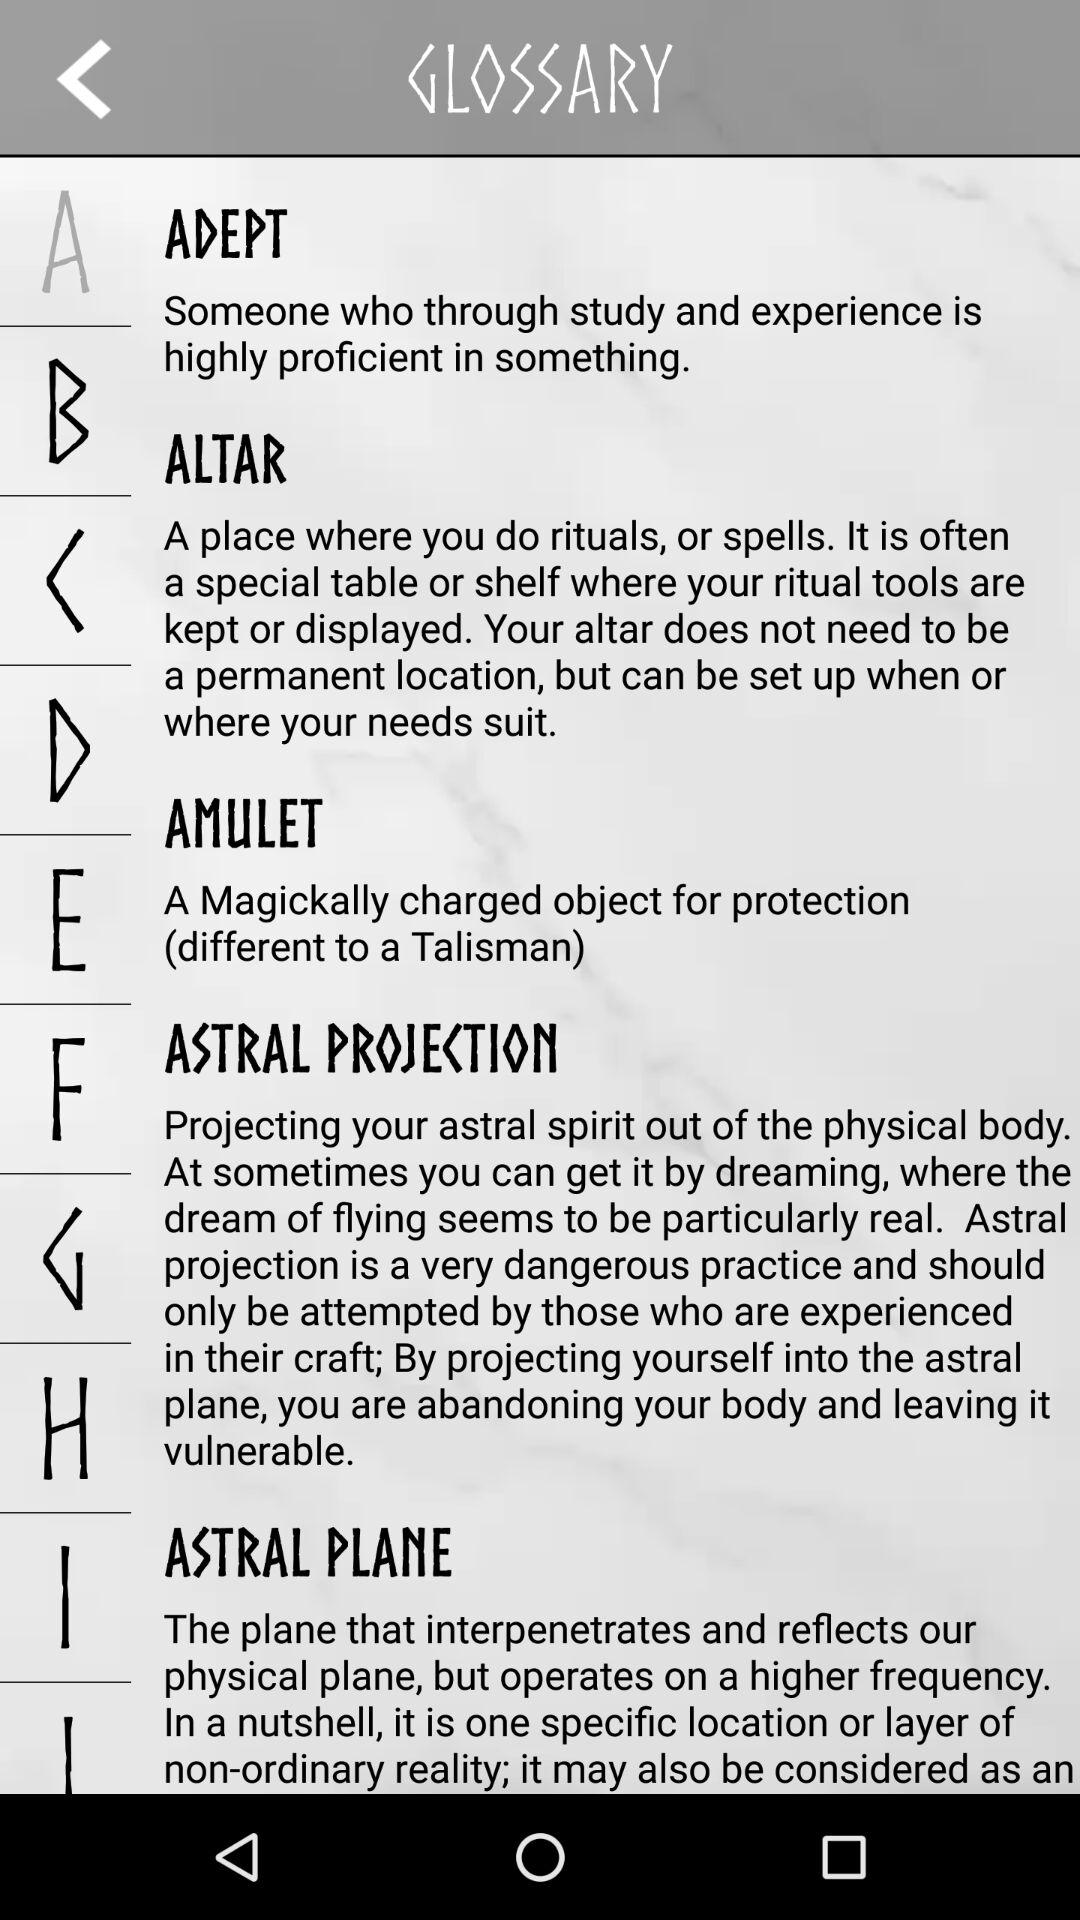Which alphabet is selected? The selected alphabet is "A". 